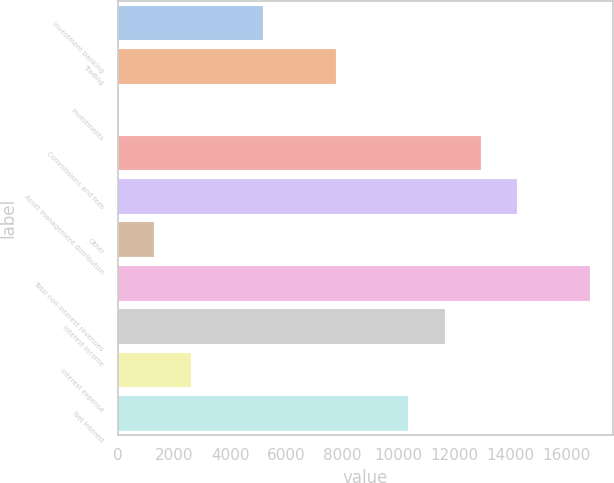Convert chart to OTSL. <chart><loc_0><loc_0><loc_500><loc_500><bar_chart><fcel>Investment banking<fcel>Trading<fcel>Investments<fcel>Commissions and fees<fcel>Asset management distribution<fcel>Other<fcel>Total non-interest revenues<fcel>Interest income<fcel>Interest expense<fcel>Net interest<nl><fcel>5184.8<fcel>7772.2<fcel>10<fcel>12947<fcel>14240.7<fcel>1303.7<fcel>16828.1<fcel>11653.3<fcel>2597.4<fcel>10359.6<nl></chart> 